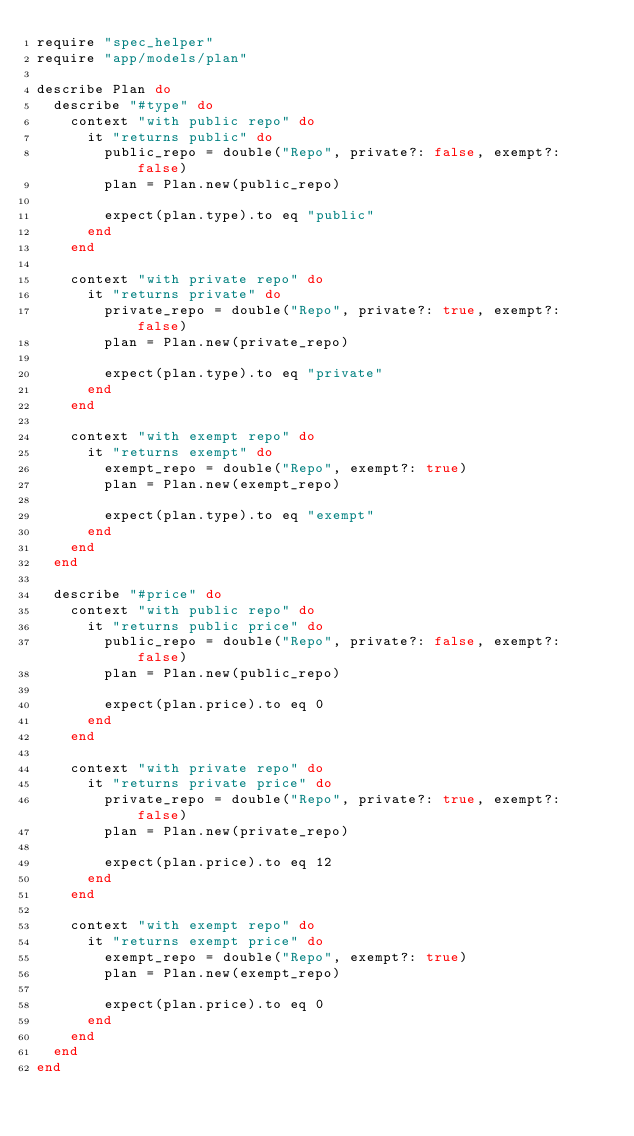<code> <loc_0><loc_0><loc_500><loc_500><_Ruby_>require "spec_helper"
require "app/models/plan"

describe Plan do
  describe "#type" do
    context "with public repo" do
      it "returns public" do
        public_repo = double("Repo", private?: false, exempt?: false)
        plan = Plan.new(public_repo)

        expect(plan.type).to eq "public"
      end
    end

    context "with private repo" do
      it "returns private" do
        private_repo = double("Repo", private?: true, exempt?: false)
        plan = Plan.new(private_repo)

        expect(plan.type).to eq "private"
      end
    end

    context "with exempt repo" do
      it "returns exempt" do
        exempt_repo = double("Repo", exempt?: true)
        plan = Plan.new(exempt_repo)

        expect(plan.type).to eq "exempt"
      end
    end
  end

  describe "#price" do
    context "with public repo" do
      it "returns public price" do
        public_repo = double("Repo", private?: false, exempt?: false)
        plan = Plan.new(public_repo)

        expect(plan.price).to eq 0
      end
    end

    context "with private repo" do
      it "returns private price" do
        private_repo = double("Repo", private?: true, exempt?: false)
        plan = Plan.new(private_repo)

        expect(plan.price).to eq 12
      end
    end

    context "with exempt repo" do
      it "returns exempt price" do
        exempt_repo = double("Repo", exempt?: true)
        plan = Plan.new(exempt_repo)

        expect(plan.price).to eq 0
      end
    end
  end
end
</code> 